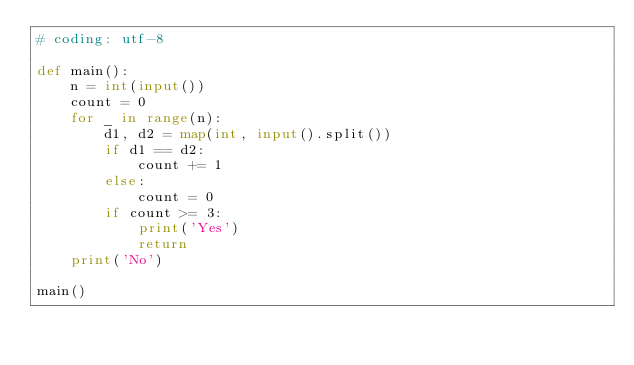Convert code to text. <code><loc_0><loc_0><loc_500><loc_500><_Python_># coding: utf-8

def main():
    n = int(input())
    count = 0
    for _ in range(n):
        d1, d2 = map(int, input().split())
        if d1 == d2:
            count += 1
        else:
            count = 0
        if count >= 3:
            print('Yes')
            return
    print('No')
    
main()

</code> 